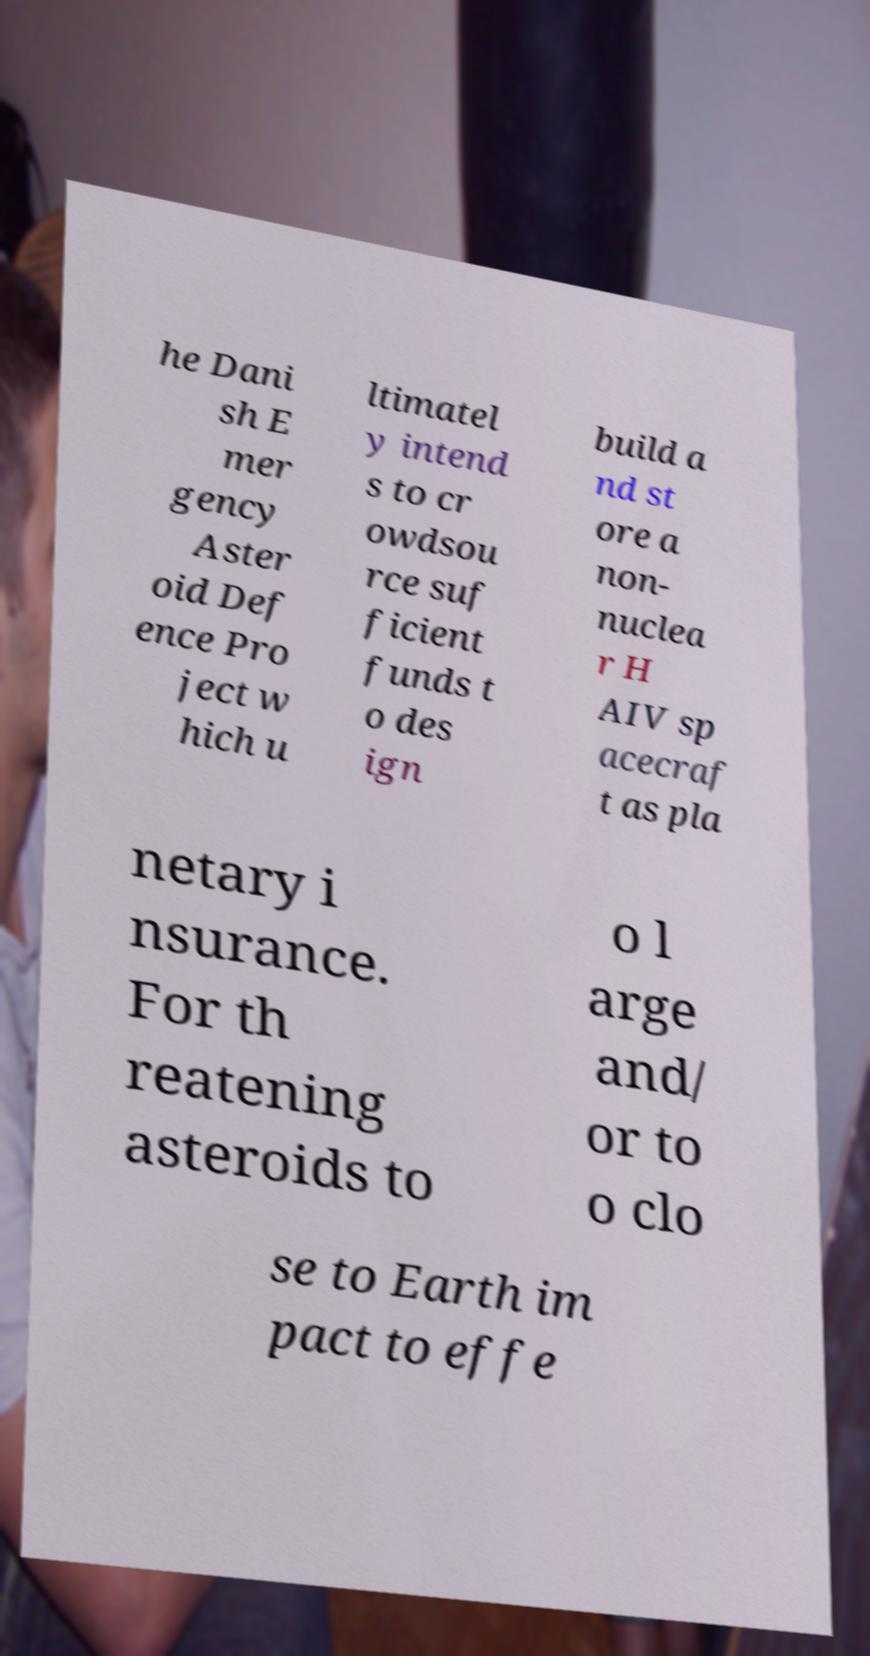Can you read and provide the text displayed in the image?This photo seems to have some interesting text. Can you extract and type it out for me? he Dani sh E mer gency Aster oid Def ence Pro ject w hich u ltimatel y intend s to cr owdsou rce suf ficient funds t o des ign build a nd st ore a non- nuclea r H AIV sp acecraf t as pla netary i nsurance. For th reatening asteroids to o l arge and/ or to o clo se to Earth im pact to effe 